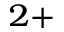Convert formula to latex. <formula><loc_0><loc_0><loc_500><loc_500>^ { 2 + }</formula> 